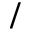Convert formula to latex. <formula><loc_0><loc_0><loc_500><loc_500>/</formula> 